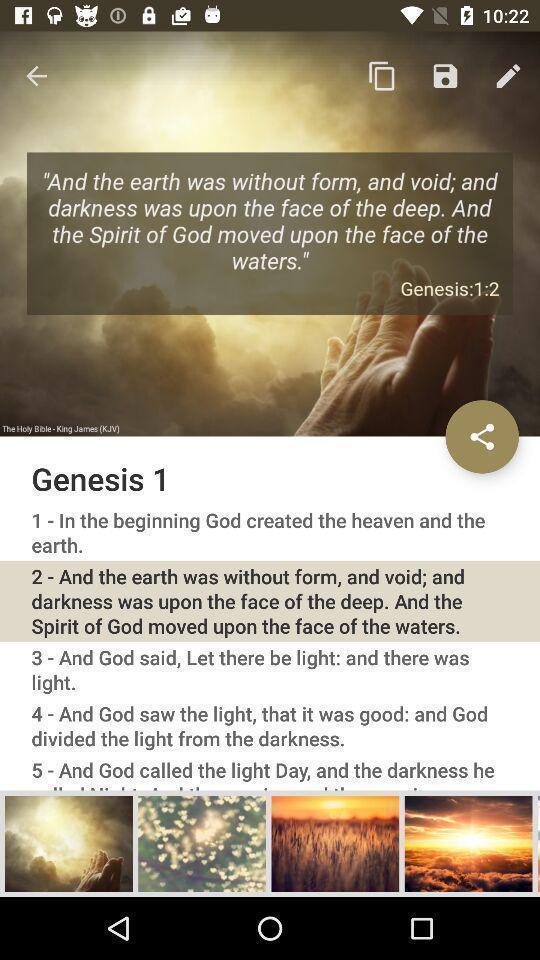Summarize the information in this screenshot. Screen page of a bible app. 